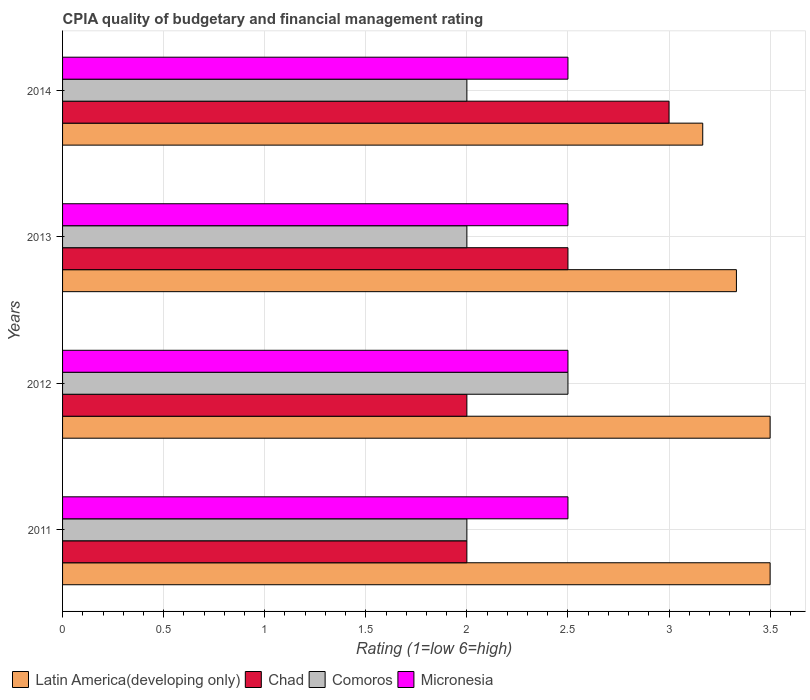How many different coloured bars are there?
Your answer should be very brief. 4. Are the number of bars per tick equal to the number of legend labels?
Offer a terse response. Yes. Are the number of bars on each tick of the Y-axis equal?
Ensure brevity in your answer.  Yes. How many bars are there on the 1st tick from the top?
Ensure brevity in your answer.  4. In how many cases, is the number of bars for a given year not equal to the number of legend labels?
Provide a succinct answer. 0. Across all years, what is the minimum CPIA rating in Comoros?
Your response must be concise. 2. In which year was the CPIA rating in Micronesia maximum?
Keep it short and to the point. 2011. In which year was the CPIA rating in Micronesia minimum?
Ensure brevity in your answer.  2011. What is the difference between the CPIA rating in Comoros in 2011 and the CPIA rating in Micronesia in 2013?
Provide a succinct answer. -0.5. What is the average CPIA rating in Latin America(developing only) per year?
Your response must be concise. 3.38. In the year 2013, what is the difference between the CPIA rating in Latin America(developing only) and CPIA rating in Micronesia?
Give a very brief answer. 0.83. In how many years, is the CPIA rating in Latin America(developing only) greater than 2 ?
Your answer should be very brief. 4. What is the ratio of the CPIA rating in Latin America(developing only) in 2011 to that in 2014?
Offer a terse response. 1.11. What is the difference between the highest and the lowest CPIA rating in Comoros?
Keep it short and to the point. 0.5. What does the 2nd bar from the top in 2014 represents?
Keep it short and to the point. Comoros. What does the 3rd bar from the bottom in 2012 represents?
Your answer should be compact. Comoros. Is it the case that in every year, the sum of the CPIA rating in Chad and CPIA rating in Comoros is greater than the CPIA rating in Micronesia?
Provide a succinct answer. Yes. Are all the bars in the graph horizontal?
Your answer should be very brief. Yes. How many years are there in the graph?
Give a very brief answer. 4. What is the difference between two consecutive major ticks on the X-axis?
Your answer should be very brief. 0.5. Are the values on the major ticks of X-axis written in scientific E-notation?
Make the answer very short. No. Does the graph contain grids?
Provide a short and direct response. Yes. Where does the legend appear in the graph?
Provide a succinct answer. Bottom left. How are the legend labels stacked?
Your answer should be compact. Horizontal. What is the title of the graph?
Your response must be concise. CPIA quality of budgetary and financial management rating. Does "Brunei Darussalam" appear as one of the legend labels in the graph?
Your answer should be very brief. No. What is the Rating (1=low 6=high) in Latin America(developing only) in 2011?
Your answer should be very brief. 3.5. What is the Rating (1=low 6=high) in Chad in 2011?
Give a very brief answer. 2. What is the Rating (1=low 6=high) in Micronesia in 2011?
Your response must be concise. 2.5. What is the Rating (1=low 6=high) in Latin America(developing only) in 2013?
Your answer should be compact. 3.33. What is the Rating (1=low 6=high) of Chad in 2013?
Offer a terse response. 2.5. What is the Rating (1=low 6=high) in Micronesia in 2013?
Offer a very short reply. 2.5. What is the Rating (1=low 6=high) in Latin America(developing only) in 2014?
Keep it short and to the point. 3.17. Across all years, what is the maximum Rating (1=low 6=high) in Micronesia?
Ensure brevity in your answer.  2.5. Across all years, what is the minimum Rating (1=low 6=high) of Latin America(developing only)?
Your answer should be very brief. 3.17. Across all years, what is the minimum Rating (1=low 6=high) in Chad?
Your response must be concise. 2. Across all years, what is the minimum Rating (1=low 6=high) of Comoros?
Ensure brevity in your answer.  2. What is the total Rating (1=low 6=high) in Latin America(developing only) in the graph?
Offer a very short reply. 13.5. What is the difference between the Rating (1=low 6=high) in Latin America(developing only) in 2011 and that in 2012?
Your answer should be compact. 0. What is the difference between the Rating (1=low 6=high) in Chad in 2011 and that in 2012?
Keep it short and to the point. 0. What is the difference between the Rating (1=low 6=high) in Micronesia in 2011 and that in 2013?
Offer a terse response. 0. What is the difference between the Rating (1=low 6=high) of Chad in 2011 and that in 2014?
Offer a terse response. -1. What is the difference between the Rating (1=low 6=high) of Chad in 2012 and that in 2014?
Your answer should be very brief. -1. What is the difference between the Rating (1=low 6=high) in Micronesia in 2012 and that in 2014?
Keep it short and to the point. 0. What is the difference between the Rating (1=low 6=high) in Latin America(developing only) in 2013 and that in 2014?
Offer a terse response. 0.17. What is the difference between the Rating (1=low 6=high) of Latin America(developing only) in 2011 and the Rating (1=low 6=high) of Chad in 2012?
Ensure brevity in your answer.  1.5. What is the difference between the Rating (1=low 6=high) in Latin America(developing only) in 2011 and the Rating (1=low 6=high) in Micronesia in 2012?
Offer a terse response. 1. What is the difference between the Rating (1=low 6=high) in Chad in 2011 and the Rating (1=low 6=high) in Comoros in 2012?
Provide a succinct answer. -0.5. What is the difference between the Rating (1=low 6=high) in Latin America(developing only) in 2011 and the Rating (1=low 6=high) in Chad in 2013?
Provide a short and direct response. 1. What is the difference between the Rating (1=low 6=high) in Latin America(developing only) in 2011 and the Rating (1=low 6=high) in Comoros in 2013?
Offer a terse response. 1.5. What is the difference between the Rating (1=low 6=high) in Latin America(developing only) in 2011 and the Rating (1=low 6=high) in Micronesia in 2013?
Provide a succinct answer. 1. What is the difference between the Rating (1=low 6=high) in Chad in 2011 and the Rating (1=low 6=high) in Comoros in 2013?
Your answer should be very brief. 0. What is the difference between the Rating (1=low 6=high) of Latin America(developing only) in 2011 and the Rating (1=low 6=high) of Chad in 2014?
Your answer should be compact. 0.5. What is the difference between the Rating (1=low 6=high) in Latin America(developing only) in 2011 and the Rating (1=low 6=high) in Micronesia in 2014?
Provide a succinct answer. 1. What is the difference between the Rating (1=low 6=high) of Chad in 2011 and the Rating (1=low 6=high) of Comoros in 2014?
Ensure brevity in your answer.  0. What is the difference between the Rating (1=low 6=high) of Chad in 2011 and the Rating (1=low 6=high) of Micronesia in 2014?
Provide a short and direct response. -0.5. What is the difference between the Rating (1=low 6=high) of Comoros in 2011 and the Rating (1=low 6=high) of Micronesia in 2014?
Ensure brevity in your answer.  -0.5. What is the difference between the Rating (1=low 6=high) in Latin America(developing only) in 2012 and the Rating (1=low 6=high) in Chad in 2013?
Give a very brief answer. 1. What is the difference between the Rating (1=low 6=high) of Latin America(developing only) in 2012 and the Rating (1=low 6=high) of Comoros in 2013?
Keep it short and to the point. 1.5. What is the difference between the Rating (1=low 6=high) in Latin America(developing only) in 2012 and the Rating (1=low 6=high) in Micronesia in 2013?
Keep it short and to the point. 1. What is the difference between the Rating (1=low 6=high) in Chad in 2012 and the Rating (1=low 6=high) in Comoros in 2013?
Your answer should be compact. 0. What is the difference between the Rating (1=low 6=high) in Latin America(developing only) in 2012 and the Rating (1=low 6=high) in Chad in 2014?
Your response must be concise. 0.5. What is the difference between the Rating (1=low 6=high) in Latin America(developing only) in 2012 and the Rating (1=low 6=high) in Micronesia in 2014?
Keep it short and to the point. 1. What is the difference between the Rating (1=low 6=high) in Comoros in 2012 and the Rating (1=low 6=high) in Micronesia in 2014?
Provide a short and direct response. 0. What is the difference between the Rating (1=low 6=high) in Latin America(developing only) in 2013 and the Rating (1=low 6=high) in Chad in 2014?
Your answer should be compact. 0.33. What is the average Rating (1=low 6=high) of Latin America(developing only) per year?
Give a very brief answer. 3.38. What is the average Rating (1=low 6=high) of Chad per year?
Make the answer very short. 2.38. What is the average Rating (1=low 6=high) in Comoros per year?
Offer a terse response. 2.12. What is the average Rating (1=low 6=high) in Micronesia per year?
Give a very brief answer. 2.5. In the year 2011, what is the difference between the Rating (1=low 6=high) in Latin America(developing only) and Rating (1=low 6=high) in Chad?
Provide a short and direct response. 1.5. In the year 2011, what is the difference between the Rating (1=low 6=high) of Chad and Rating (1=low 6=high) of Micronesia?
Your response must be concise. -0.5. In the year 2011, what is the difference between the Rating (1=low 6=high) of Comoros and Rating (1=low 6=high) of Micronesia?
Make the answer very short. -0.5. In the year 2012, what is the difference between the Rating (1=low 6=high) of Latin America(developing only) and Rating (1=low 6=high) of Chad?
Make the answer very short. 1.5. In the year 2012, what is the difference between the Rating (1=low 6=high) in Latin America(developing only) and Rating (1=low 6=high) in Micronesia?
Provide a succinct answer. 1. In the year 2012, what is the difference between the Rating (1=low 6=high) of Chad and Rating (1=low 6=high) of Comoros?
Your answer should be compact. -0.5. In the year 2012, what is the difference between the Rating (1=low 6=high) of Comoros and Rating (1=low 6=high) of Micronesia?
Offer a very short reply. 0. In the year 2014, what is the difference between the Rating (1=low 6=high) in Latin America(developing only) and Rating (1=low 6=high) in Comoros?
Your answer should be compact. 1.17. In the year 2014, what is the difference between the Rating (1=low 6=high) in Comoros and Rating (1=low 6=high) in Micronesia?
Ensure brevity in your answer.  -0.5. What is the ratio of the Rating (1=low 6=high) in Chad in 2011 to that in 2013?
Ensure brevity in your answer.  0.8. What is the ratio of the Rating (1=low 6=high) in Micronesia in 2011 to that in 2013?
Provide a succinct answer. 1. What is the ratio of the Rating (1=low 6=high) in Latin America(developing only) in 2011 to that in 2014?
Keep it short and to the point. 1.11. What is the ratio of the Rating (1=low 6=high) of Micronesia in 2011 to that in 2014?
Keep it short and to the point. 1. What is the ratio of the Rating (1=low 6=high) of Latin America(developing only) in 2012 to that in 2013?
Your answer should be compact. 1.05. What is the ratio of the Rating (1=low 6=high) of Micronesia in 2012 to that in 2013?
Ensure brevity in your answer.  1. What is the ratio of the Rating (1=low 6=high) of Latin America(developing only) in 2012 to that in 2014?
Provide a succinct answer. 1.11. What is the ratio of the Rating (1=low 6=high) in Comoros in 2012 to that in 2014?
Your answer should be very brief. 1.25. What is the ratio of the Rating (1=low 6=high) in Micronesia in 2012 to that in 2014?
Offer a terse response. 1. What is the ratio of the Rating (1=low 6=high) in Latin America(developing only) in 2013 to that in 2014?
Your response must be concise. 1.05. What is the ratio of the Rating (1=low 6=high) in Chad in 2013 to that in 2014?
Ensure brevity in your answer.  0.83. What is the ratio of the Rating (1=low 6=high) in Micronesia in 2013 to that in 2014?
Ensure brevity in your answer.  1. What is the difference between the highest and the second highest Rating (1=low 6=high) in Chad?
Your answer should be very brief. 0.5. What is the difference between the highest and the second highest Rating (1=low 6=high) of Comoros?
Your answer should be very brief. 0.5. What is the difference between the highest and the second highest Rating (1=low 6=high) of Micronesia?
Your response must be concise. 0. What is the difference between the highest and the lowest Rating (1=low 6=high) of Micronesia?
Your answer should be very brief. 0. 